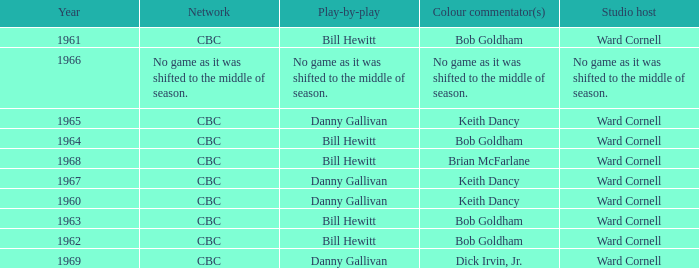Who gave the play by play commentary with studio host Ward Cornell? Danny Gallivan, Bill Hewitt, Danny Gallivan, Danny Gallivan, Bill Hewitt, Bill Hewitt, Bill Hewitt, Bill Hewitt, Danny Gallivan. 